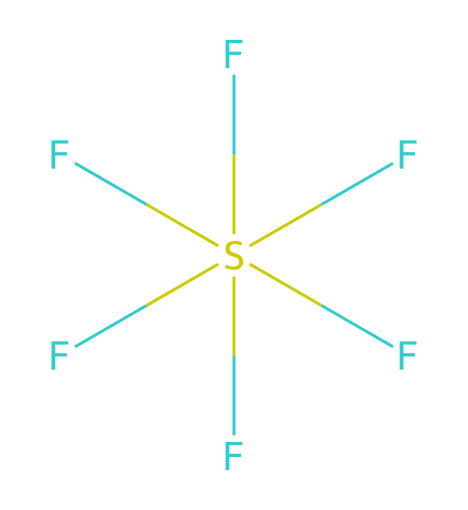What is the chemical name of this compound? The structure provided corresponds to sulfur hexafluoride, composed of one sulfur atom bonded to six fluorine atoms.
Answer: sulfur hexafluoride How many total atoms are present in this molecule? Counting the sulfur atom (1) and the six fluorine atoms (6), there are a total of 1 + 6 = 7 atoms.
Answer: 7 What type of hybridization is observed in sulfur hexafluoride? The sulfur atom in this molecule uses sp3d2 hybridization to accommodate six bonding pairs with fluorine atoms.
Answer: sp3d2 What is the molecular geometry of sulfur hexafluoride? Given the six bonded fluorine atoms and no lone pairs on the sulfur, the molecular shape is octahedral.
Answer: octahedral Is sulfur hexafluoride a hypervalent compound? Yes, sulfur hexafluoride is a hypervalent compound as the sulfur atom has more than four bonding pairs to other atoms.
Answer: Yes What is the primary use of sulfur hexafluoride in electrical engineering? Sulfur hexafluoride is primarily used as an insulator in high voltage applications due to its excellent dielectric properties.
Answer: insulator 